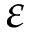<formula> <loc_0><loc_0><loc_500><loc_500>\varepsilon</formula> 